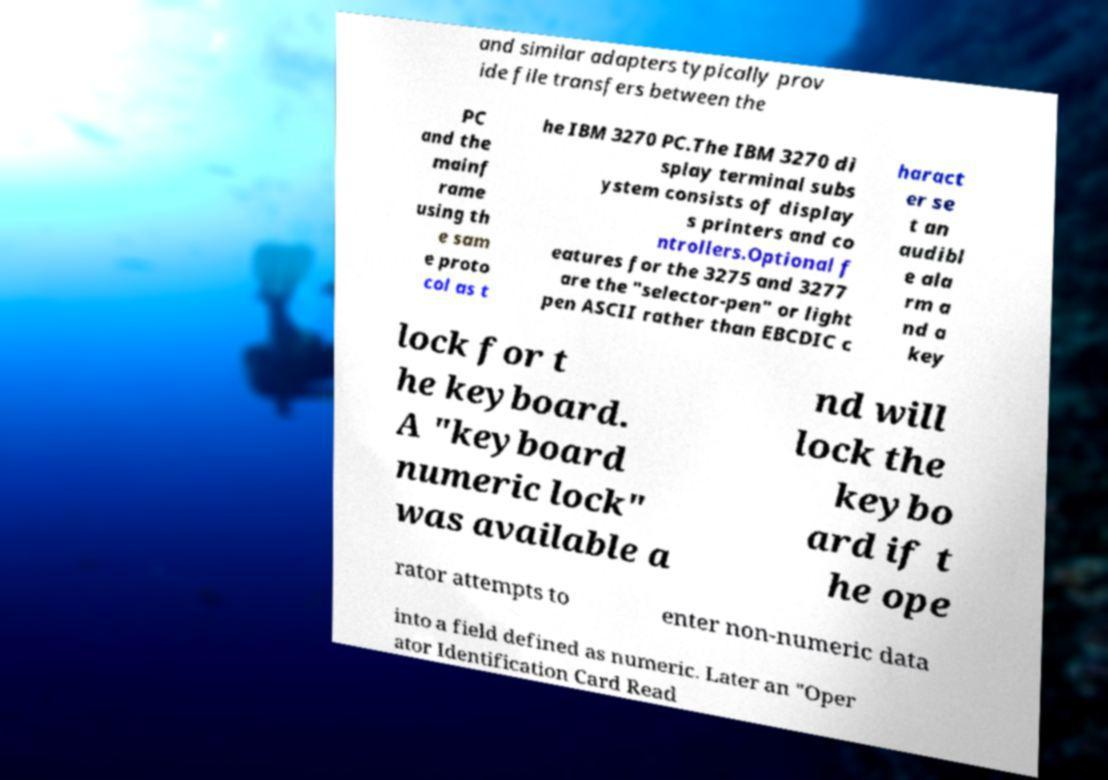Please read and relay the text visible in this image. What does it say? and similar adapters typically prov ide file transfers between the PC and the mainf rame using th e sam e proto col as t he IBM 3270 PC.The IBM 3270 di splay terminal subs ystem consists of display s printers and co ntrollers.Optional f eatures for the 3275 and 3277 are the "selector-pen" or light pen ASCII rather than EBCDIC c haract er se t an audibl e ala rm a nd a key lock for t he keyboard. A "keyboard numeric lock" was available a nd will lock the keybo ard if t he ope rator attempts to enter non-numeric data into a field defined as numeric. Later an "Oper ator Identification Card Read 